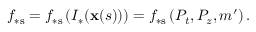<formula> <loc_0><loc_0><loc_500><loc_500>f _ { \ast s } = f _ { \ast s } \left ( I _ { \ast } ( x ( s ) ) \right ) = f _ { \ast s } \left ( P _ { t } , P _ { z } , m ^ { \prime } \right ) .</formula> 